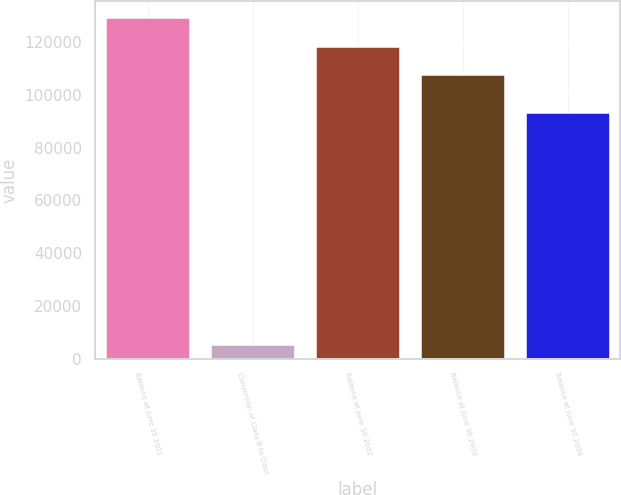Convert chart. <chart><loc_0><loc_0><loc_500><loc_500><bar_chart><fcel>Balance at June 30 2001<fcel>Conversion of Class B to Class<fcel>Balance at June 30 2002<fcel>Balance at June 30 2003<fcel>Balance at June 30 2004<nl><fcel>129145<fcel>5077.8<fcel>118304<fcel>107462<fcel>93012.9<nl></chart> 